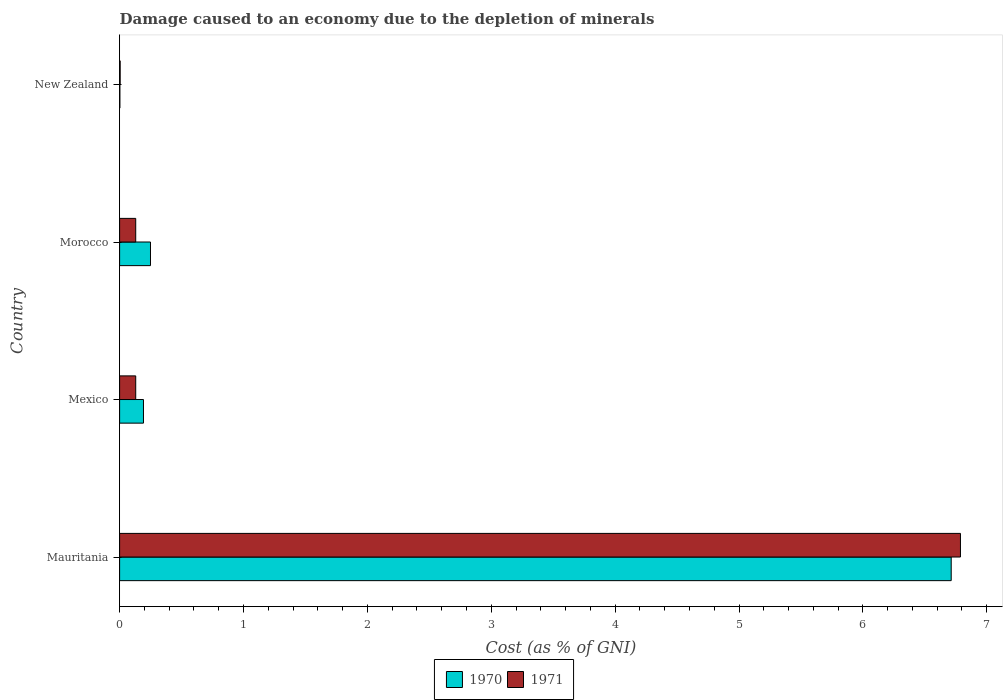Are the number of bars per tick equal to the number of legend labels?
Keep it short and to the point. Yes. Are the number of bars on each tick of the Y-axis equal?
Your answer should be very brief. Yes. What is the label of the 2nd group of bars from the top?
Your answer should be very brief. Morocco. In how many cases, is the number of bars for a given country not equal to the number of legend labels?
Offer a very short reply. 0. What is the cost of damage caused due to the depletion of minerals in 1970 in Mauritania?
Your answer should be very brief. 6.71. Across all countries, what is the maximum cost of damage caused due to the depletion of minerals in 1970?
Offer a very short reply. 6.71. Across all countries, what is the minimum cost of damage caused due to the depletion of minerals in 1971?
Make the answer very short. 0. In which country was the cost of damage caused due to the depletion of minerals in 1971 maximum?
Keep it short and to the point. Mauritania. In which country was the cost of damage caused due to the depletion of minerals in 1971 minimum?
Your answer should be compact. New Zealand. What is the total cost of damage caused due to the depletion of minerals in 1971 in the graph?
Provide a short and direct response. 7.05. What is the difference between the cost of damage caused due to the depletion of minerals in 1970 in Mexico and that in Morocco?
Offer a terse response. -0.06. What is the difference between the cost of damage caused due to the depletion of minerals in 1970 in New Zealand and the cost of damage caused due to the depletion of minerals in 1971 in Morocco?
Offer a terse response. -0.13. What is the average cost of damage caused due to the depletion of minerals in 1971 per country?
Your answer should be very brief. 1.76. What is the difference between the cost of damage caused due to the depletion of minerals in 1971 and cost of damage caused due to the depletion of minerals in 1970 in New Zealand?
Provide a succinct answer. 0. In how many countries, is the cost of damage caused due to the depletion of minerals in 1970 greater than 2.6 %?
Ensure brevity in your answer.  1. What is the ratio of the cost of damage caused due to the depletion of minerals in 1970 in Mauritania to that in New Zealand?
Keep it short and to the point. 3002.84. Is the difference between the cost of damage caused due to the depletion of minerals in 1971 in Morocco and New Zealand greater than the difference between the cost of damage caused due to the depletion of minerals in 1970 in Morocco and New Zealand?
Ensure brevity in your answer.  No. What is the difference between the highest and the second highest cost of damage caused due to the depletion of minerals in 1970?
Your answer should be compact. 6.46. What is the difference between the highest and the lowest cost of damage caused due to the depletion of minerals in 1971?
Your answer should be very brief. 6.78. In how many countries, is the cost of damage caused due to the depletion of minerals in 1971 greater than the average cost of damage caused due to the depletion of minerals in 1971 taken over all countries?
Your response must be concise. 1. Is the sum of the cost of damage caused due to the depletion of minerals in 1971 in Mauritania and New Zealand greater than the maximum cost of damage caused due to the depletion of minerals in 1970 across all countries?
Your answer should be compact. Yes. What does the 2nd bar from the top in Morocco represents?
Provide a succinct answer. 1970. What does the 2nd bar from the bottom in Mauritania represents?
Provide a short and direct response. 1971. How many bars are there?
Offer a very short reply. 8. Are the values on the major ticks of X-axis written in scientific E-notation?
Keep it short and to the point. No. Does the graph contain grids?
Keep it short and to the point. No. What is the title of the graph?
Ensure brevity in your answer.  Damage caused to an economy due to the depletion of minerals. What is the label or title of the X-axis?
Offer a very short reply. Cost (as % of GNI). What is the Cost (as % of GNI) in 1970 in Mauritania?
Provide a succinct answer. 6.71. What is the Cost (as % of GNI) in 1971 in Mauritania?
Your answer should be very brief. 6.79. What is the Cost (as % of GNI) in 1970 in Mexico?
Provide a succinct answer. 0.19. What is the Cost (as % of GNI) in 1971 in Mexico?
Provide a succinct answer. 0.13. What is the Cost (as % of GNI) in 1970 in Morocco?
Offer a terse response. 0.25. What is the Cost (as % of GNI) in 1971 in Morocco?
Offer a very short reply. 0.13. What is the Cost (as % of GNI) in 1970 in New Zealand?
Offer a terse response. 0. What is the Cost (as % of GNI) of 1971 in New Zealand?
Make the answer very short. 0. Across all countries, what is the maximum Cost (as % of GNI) in 1970?
Your answer should be compact. 6.71. Across all countries, what is the maximum Cost (as % of GNI) of 1971?
Provide a short and direct response. 6.79. Across all countries, what is the minimum Cost (as % of GNI) of 1970?
Your response must be concise. 0. Across all countries, what is the minimum Cost (as % of GNI) of 1971?
Your answer should be very brief. 0. What is the total Cost (as % of GNI) of 1970 in the graph?
Your response must be concise. 7.16. What is the total Cost (as % of GNI) in 1971 in the graph?
Ensure brevity in your answer.  7.05. What is the difference between the Cost (as % of GNI) in 1970 in Mauritania and that in Mexico?
Provide a short and direct response. 6.52. What is the difference between the Cost (as % of GNI) of 1971 in Mauritania and that in Mexico?
Your answer should be compact. 6.66. What is the difference between the Cost (as % of GNI) of 1970 in Mauritania and that in Morocco?
Your answer should be very brief. 6.46. What is the difference between the Cost (as % of GNI) of 1971 in Mauritania and that in Morocco?
Ensure brevity in your answer.  6.66. What is the difference between the Cost (as % of GNI) in 1970 in Mauritania and that in New Zealand?
Your answer should be very brief. 6.71. What is the difference between the Cost (as % of GNI) of 1971 in Mauritania and that in New Zealand?
Keep it short and to the point. 6.78. What is the difference between the Cost (as % of GNI) of 1970 in Mexico and that in Morocco?
Your answer should be very brief. -0.06. What is the difference between the Cost (as % of GNI) in 1970 in Mexico and that in New Zealand?
Offer a very short reply. 0.19. What is the difference between the Cost (as % of GNI) of 1971 in Mexico and that in New Zealand?
Provide a short and direct response. 0.13. What is the difference between the Cost (as % of GNI) of 1970 in Morocco and that in New Zealand?
Ensure brevity in your answer.  0.25. What is the difference between the Cost (as % of GNI) in 1971 in Morocco and that in New Zealand?
Keep it short and to the point. 0.13. What is the difference between the Cost (as % of GNI) of 1970 in Mauritania and the Cost (as % of GNI) of 1971 in Mexico?
Offer a very short reply. 6.58. What is the difference between the Cost (as % of GNI) in 1970 in Mauritania and the Cost (as % of GNI) in 1971 in Morocco?
Offer a terse response. 6.58. What is the difference between the Cost (as % of GNI) of 1970 in Mauritania and the Cost (as % of GNI) of 1971 in New Zealand?
Provide a short and direct response. 6.71. What is the difference between the Cost (as % of GNI) of 1970 in Mexico and the Cost (as % of GNI) of 1971 in Morocco?
Offer a very short reply. 0.06. What is the difference between the Cost (as % of GNI) in 1970 in Mexico and the Cost (as % of GNI) in 1971 in New Zealand?
Make the answer very short. 0.19. What is the difference between the Cost (as % of GNI) in 1970 in Morocco and the Cost (as % of GNI) in 1971 in New Zealand?
Provide a succinct answer. 0.24. What is the average Cost (as % of GNI) in 1970 per country?
Keep it short and to the point. 1.79. What is the average Cost (as % of GNI) of 1971 per country?
Your answer should be very brief. 1.76. What is the difference between the Cost (as % of GNI) of 1970 and Cost (as % of GNI) of 1971 in Mauritania?
Keep it short and to the point. -0.07. What is the difference between the Cost (as % of GNI) in 1970 and Cost (as % of GNI) in 1971 in Mexico?
Provide a succinct answer. 0.06. What is the difference between the Cost (as % of GNI) in 1970 and Cost (as % of GNI) in 1971 in Morocco?
Your answer should be compact. 0.12. What is the difference between the Cost (as % of GNI) of 1970 and Cost (as % of GNI) of 1971 in New Zealand?
Offer a terse response. -0. What is the ratio of the Cost (as % of GNI) of 1970 in Mauritania to that in Mexico?
Provide a succinct answer. 34.85. What is the ratio of the Cost (as % of GNI) of 1971 in Mauritania to that in Mexico?
Give a very brief answer. 52.15. What is the ratio of the Cost (as % of GNI) of 1970 in Mauritania to that in Morocco?
Make the answer very short. 26.93. What is the ratio of the Cost (as % of GNI) of 1971 in Mauritania to that in Morocco?
Your answer should be compact. 52.17. What is the ratio of the Cost (as % of GNI) in 1970 in Mauritania to that in New Zealand?
Give a very brief answer. 3002.84. What is the ratio of the Cost (as % of GNI) in 1971 in Mauritania to that in New Zealand?
Give a very brief answer. 1494.47. What is the ratio of the Cost (as % of GNI) in 1970 in Mexico to that in Morocco?
Your answer should be very brief. 0.77. What is the ratio of the Cost (as % of GNI) in 1970 in Mexico to that in New Zealand?
Give a very brief answer. 86.15. What is the ratio of the Cost (as % of GNI) in 1971 in Mexico to that in New Zealand?
Ensure brevity in your answer.  28.66. What is the ratio of the Cost (as % of GNI) in 1970 in Morocco to that in New Zealand?
Ensure brevity in your answer.  111.49. What is the ratio of the Cost (as % of GNI) in 1971 in Morocco to that in New Zealand?
Make the answer very short. 28.64. What is the difference between the highest and the second highest Cost (as % of GNI) of 1970?
Give a very brief answer. 6.46. What is the difference between the highest and the second highest Cost (as % of GNI) in 1971?
Offer a very short reply. 6.66. What is the difference between the highest and the lowest Cost (as % of GNI) in 1970?
Your response must be concise. 6.71. What is the difference between the highest and the lowest Cost (as % of GNI) of 1971?
Keep it short and to the point. 6.78. 